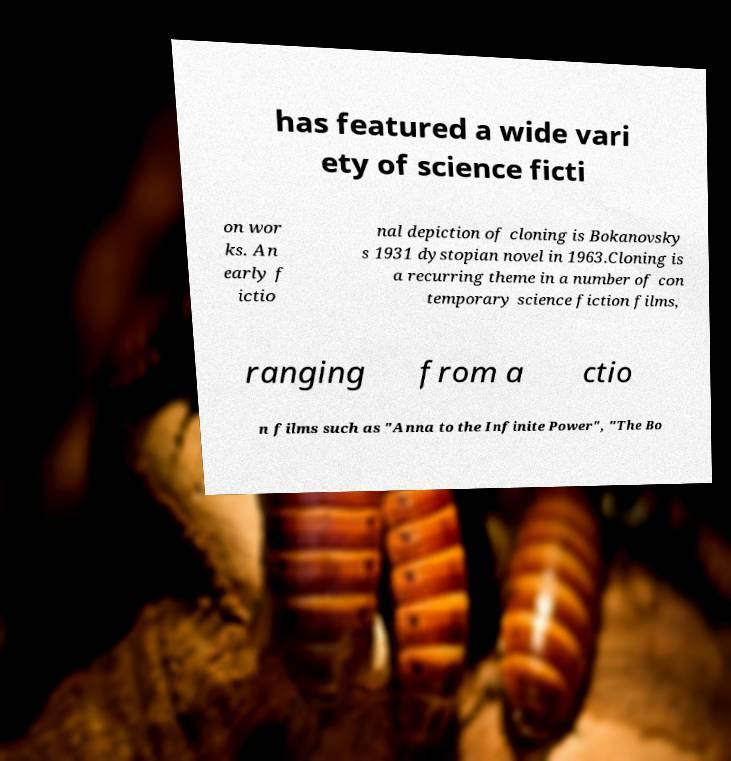Could you extract and type out the text from this image? has featured a wide vari ety of science ficti on wor ks. An early f ictio nal depiction of cloning is Bokanovsky s 1931 dystopian novel in 1963.Cloning is a recurring theme in a number of con temporary science fiction films, ranging from a ctio n films such as "Anna to the Infinite Power", "The Bo 